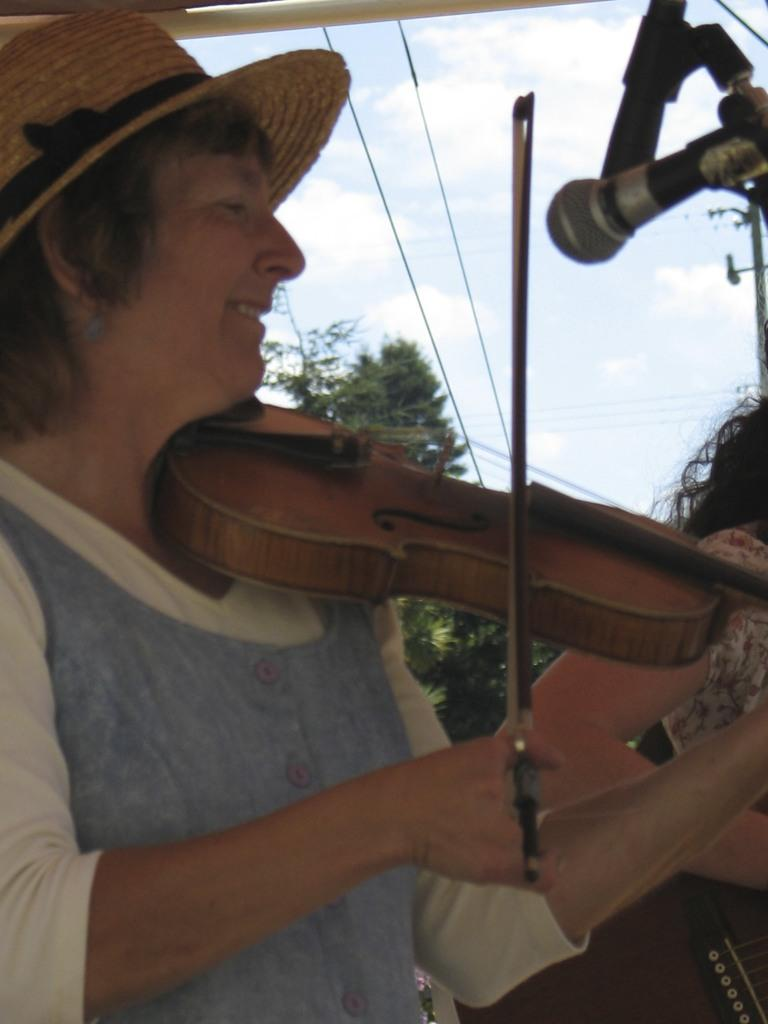What is the man in the image doing? The man is playing a violin. What is in front of the man in the image? There is a microphone with a stand in front of the man. What can be seen in the background of the image? There are trees and clouds in the background of the image. How many books can be seen on the violin in the image? There are no books present on the violin in the image. What type of zephyr is blowing through the trees in the background? There is no zephyr mentioned or depicted in the image; it simply shows trees and clouds in the background. 